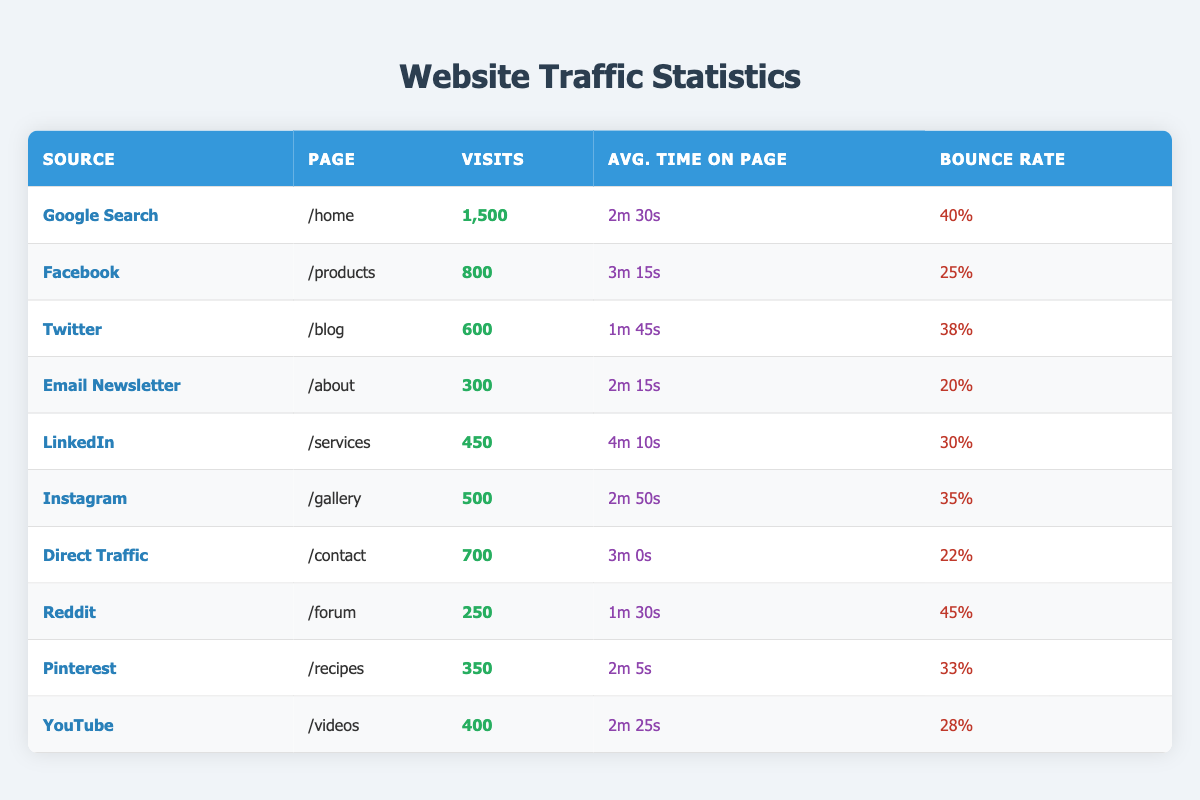What is the page with the highest number of visits? From the table, we can see that the page with the highest visits is "/home" with 1,500 visits from Google Search.
Answer: /home Which source has the lowest bounce rate? By examining the bounce rates in the table, the lowest bounce rate is reported for Email Newsletter at 20%.
Answer: Email Newsletter How many total visits were recorded from Facebook and LinkedIn combined? The visits from Facebook are 800 and from LinkedIn are 450. Adding these together gives 800 + 450 = 1,250 total visits.
Answer: 1,250 What is the average time on page for visitors coming from Twitter and Reddit? The average time on page for Twitter is 1 minute 45 seconds and for Reddit is 1 minute 30 seconds. First, we convert these into seconds (1m 45s = 105s and 1m 30s = 90s). Adding these gives 105 + 90 = 195 seconds. To find the average, divide by 2: 195 / 2 = 97.5 seconds, which is 1 minute and 37.5 seconds.
Answer: 1m 37s Did Instagram have more visits than Direct Traffic? By comparing the visits, Instagram has 500 visits, while Direct Traffic has 700 visits. Therefore, Instagram did not have more visits.
Answer: No Which source resulted in the most visits on the "/products" page? The data shows that Facebook is the only source listed with visits to the "/products" page, and it has 800 visits.
Answer: Facebook 